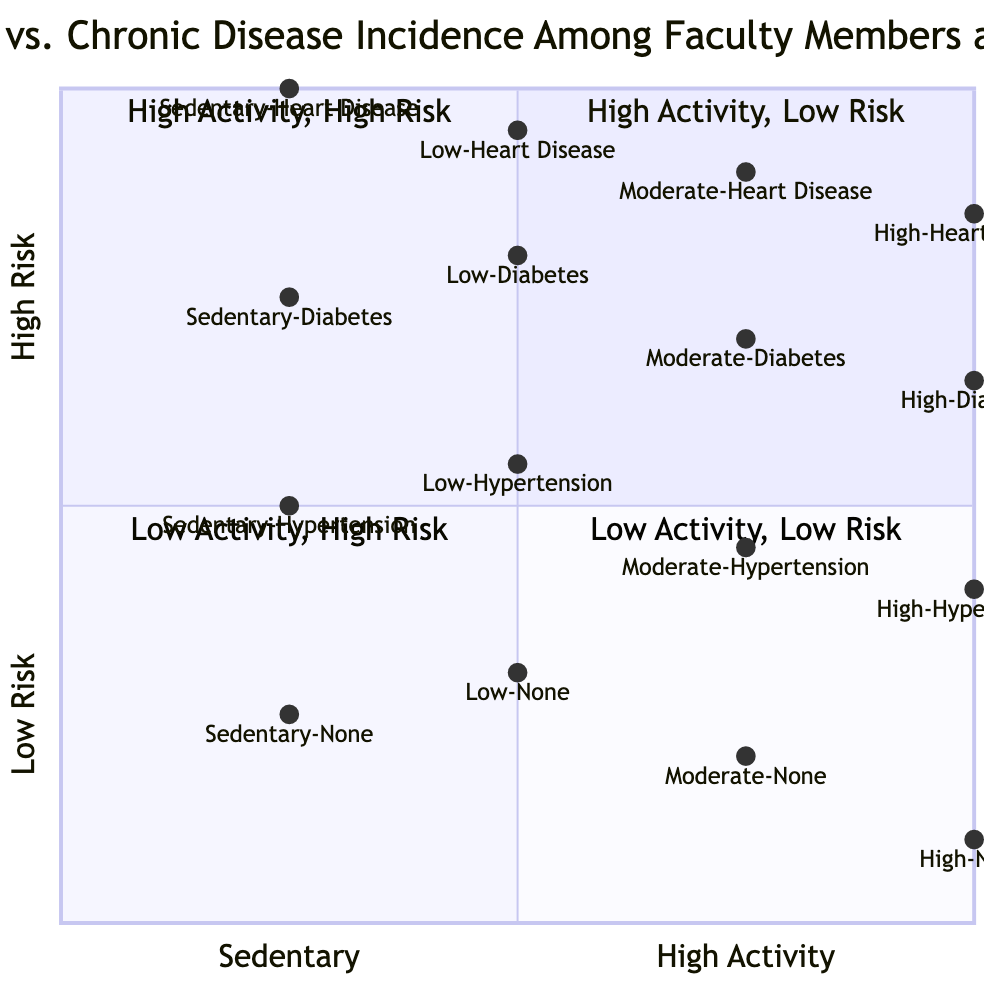What's the faculty percentage for Sedentary individuals with Heart Disease? The diagram shows that the faculty percentage for Sedentary individuals with Heart Disease is 15%, as indicated in the data for Sedentary activity levels.
Answer: 15% Which activity level corresponds to the highest incidence of Diabetes? By examining the data points for Diabetes, the highest incidence is found in the Sedentary category at 20%, compared to lower percentages in other activity levels.
Answer: Sedentary How many diseases are represented in the quadrants for High activity levels? The diagram indicates that there are three diseases represented for High activity levels: Hypertension, Diabetes, and Heart Disease, alongside the 'None' category.
Answer: 3 What is the faculty percentage of those with no chronic disease at Moderate activity levels? The data indicates that 70% of faculty members with Moderate activity levels reported having no chronic diseases.
Answer: 70% In which quadrant does the combination of High activity level and Heart Disease fall? The combination of High activity level and Heart Disease falls in Quadrant 2, which represents High Activity, High Risk, as it indicates an increase in disease despite high activity levels.
Answer: Quadrant 2 What is the lowest faculty percentage across all activity levels for chronic diseases? Upon reviewing the data, the lowest faculty percentage for chronic diseases is found in the High activity level for Heart Disease, at 3%.
Answer: 3% How does the percentage of Sedentary individuals with no chronic diseases compare to Low activity individuals with no chronic diseases? Sedentary individuals with no chronic diseases constitute 40%, while Low activity individuals with no chronic diseases account for 55%, indicating a difference of 15%.
Answer: 15% Which disease has the highest occurrence among faculty with Low activity levels? Analyzing the Low activity level data, Hypertension is the disease with the highest occurrence at 20%, compared to other diseases in the same category.
Answer: Hypertension 